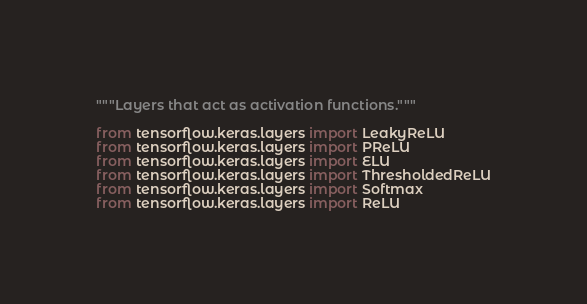<code> <loc_0><loc_0><loc_500><loc_500><_Python_>"""Layers that act as activation functions."""

from tensorflow.keras.layers import LeakyReLU
from tensorflow.keras.layers import PReLU
from tensorflow.keras.layers import ELU
from tensorflow.keras.layers import ThresholdedReLU
from tensorflow.keras.layers import Softmax
from tensorflow.keras.layers import ReLU
</code> 